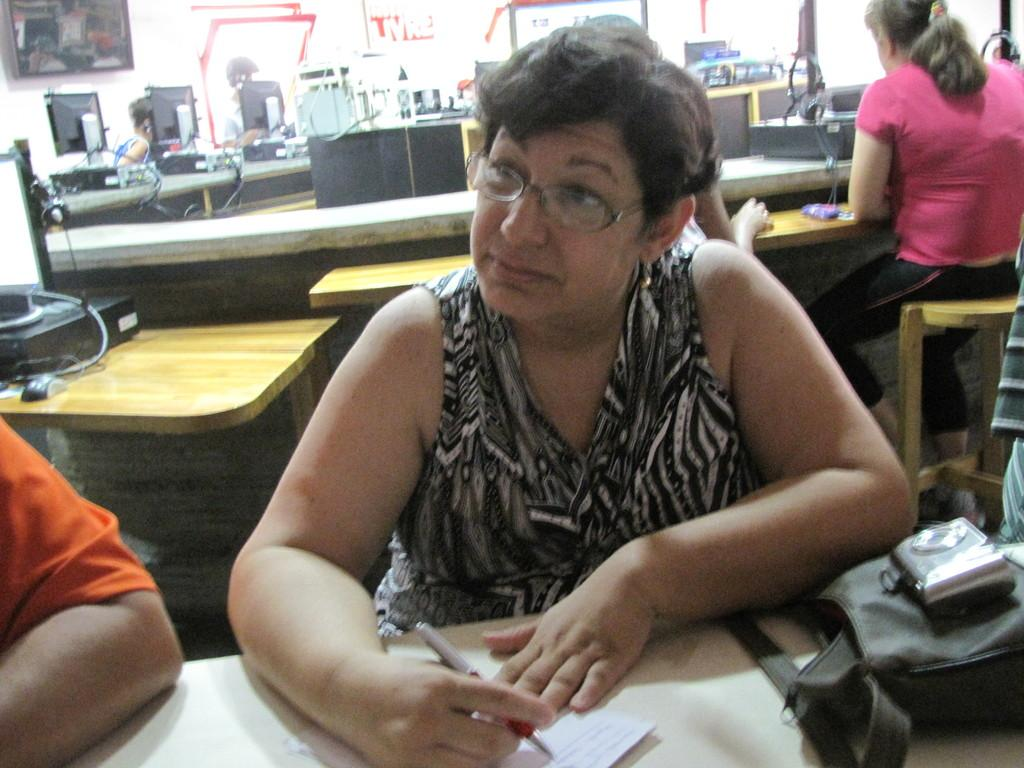What are the people in the image doing? The people in the image are sitting. What is the woman holding in her hand? The woman is holding a pen in her hand. What type of accessory can be seen in the image? There is a handbag in the image. What can be identified as electronic devices or equipment in the image? There are systems (possibly electronic devices or equipment) in the image. Is the woman driving a ship in the image? No, there is no ship or driving activity depicted in the image. What type of button can be seen on the woman's shirt in the image? There is no button visible on the woman's shirt in the image. 